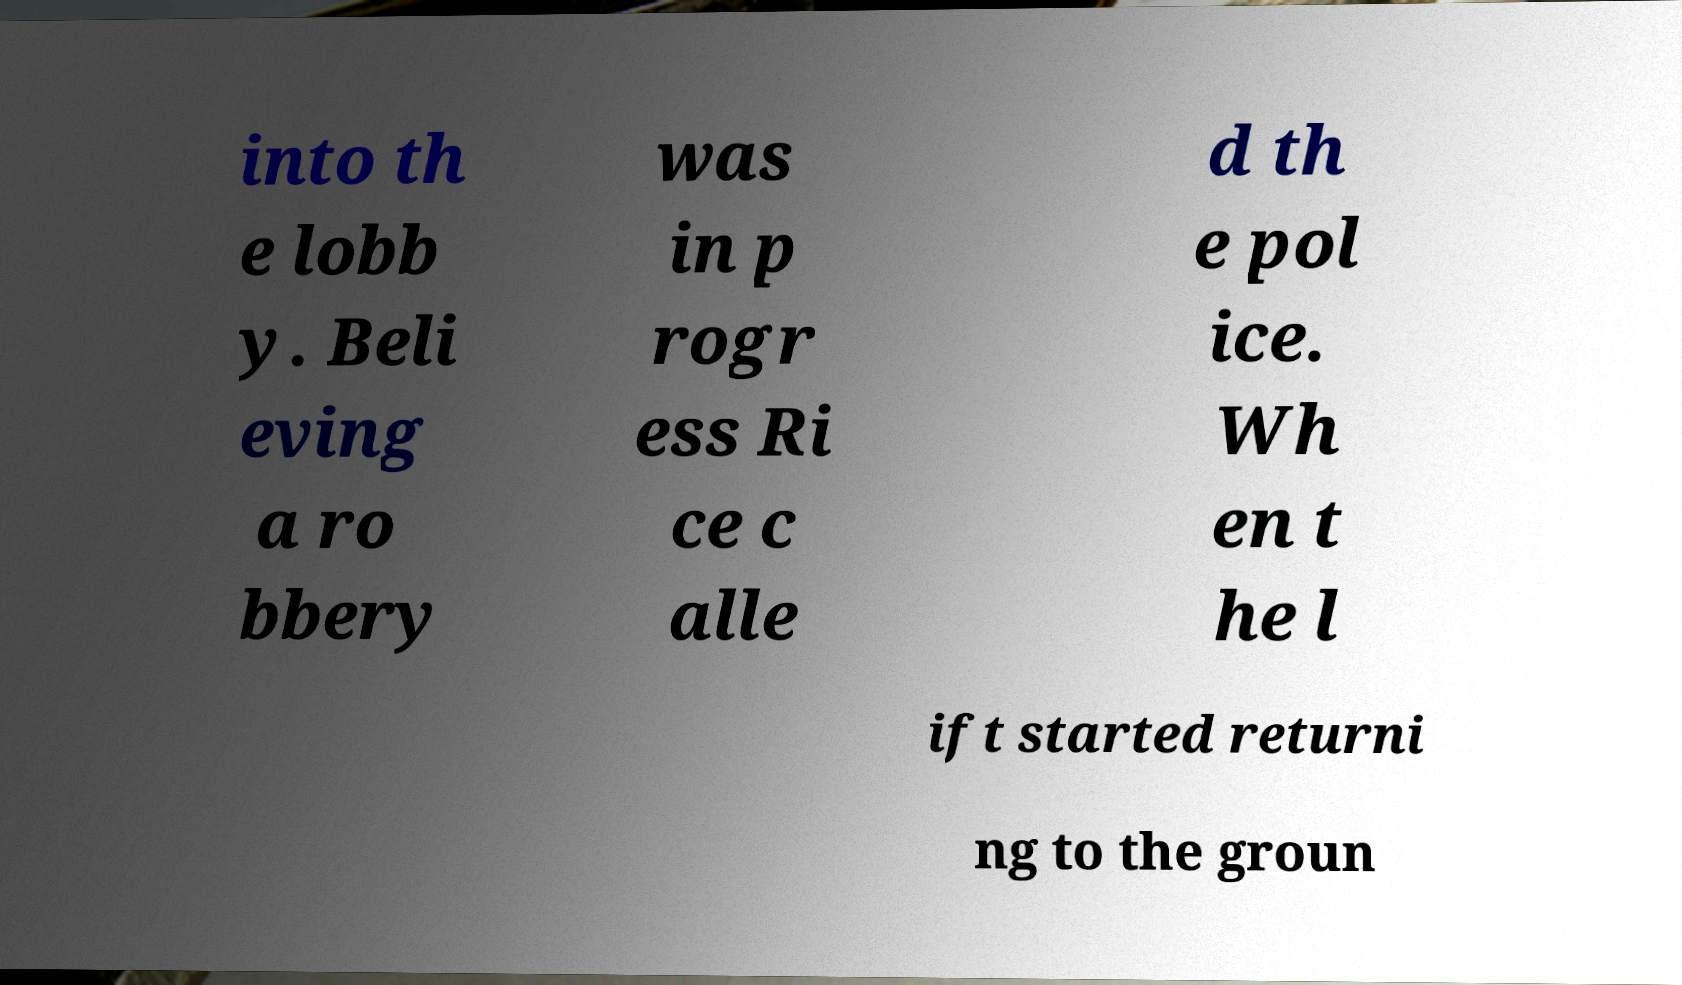Please read and relay the text visible in this image. What does it say? into th e lobb y. Beli eving a ro bbery was in p rogr ess Ri ce c alle d th e pol ice. Wh en t he l ift started returni ng to the groun 